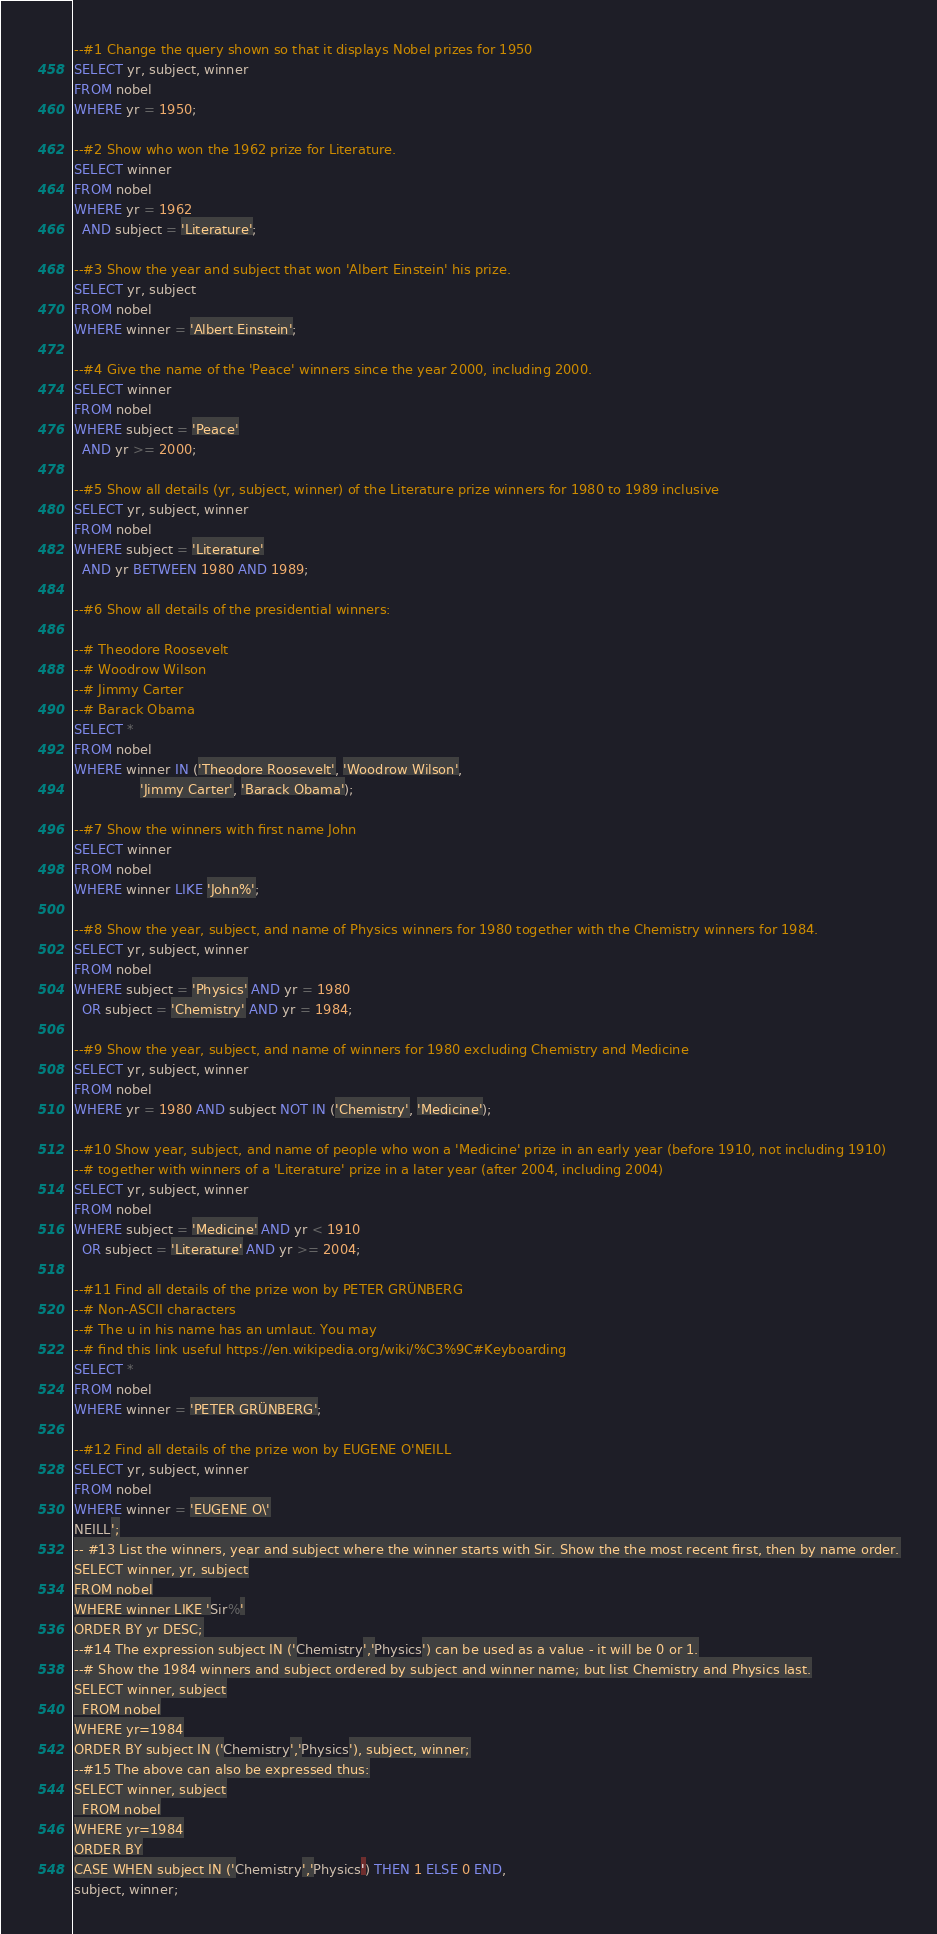Convert code to text. <code><loc_0><loc_0><loc_500><loc_500><_SQL_>--#1 Change the query shown so that it displays Nobel prizes for 1950
SELECT yr, subject, winner
FROM nobel
WHERE yr = 1950;

--#2 Show who won the 1962 prize for Literature.
SELECT winner
FROM nobel
WHERE yr = 1962
  AND subject = 'Literature';

--#3 Show the year and subject that won 'Albert Einstein' his prize.
SELECT yr, subject
FROM nobel
WHERE winner = 'Albert Einstein';

--#4 Give the name of the 'Peace' winners since the year 2000, including 2000.
SELECT winner
FROM nobel
WHERE subject = 'Peace'
  AND yr >= 2000;

--#5 Show all details (yr, subject, winner) of the Literature prize winners for 1980 to 1989 inclusive
SELECT yr, subject, winner
FROM nobel
WHERE subject = 'Literature'
  AND yr BETWEEN 1980 AND 1989;

--#6 Show all details of the presidential winners:

--# Theodore Roosevelt
--# Woodrow Wilson
--# Jimmy Carter
--# Barack Obama
SELECT *
FROM nobel
WHERE winner IN ('Theodore Roosevelt', 'Woodrow Wilson',
                'Jimmy Carter', 'Barack Obama');

--#7 Show the winners with first name John
SELECT winner
FROM nobel
WHERE winner LIKE 'John%';

--#8 Show the year, subject, and name of Physics winners for 1980 together with the Chemistry winners for 1984.
SELECT yr, subject, winner
FROM nobel
WHERE subject = 'Physics' AND yr = 1980
  OR subject = 'Chemistry' AND yr = 1984;

--#9 Show the year, subject, and name of winners for 1980 excluding Chemistry and Medicine
SELECT yr, subject, winner
FROM nobel
WHERE yr = 1980 AND subject NOT IN ('Chemistry', 'Medicine');

--#10 Show year, subject, and name of people who won a 'Medicine' prize in an early year (before 1910, not including 1910)
--# together with winners of a 'Literature' prize in a later year (after 2004, including 2004)
SELECT yr, subject, winner
FROM nobel
WHERE subject = 'Medicine' AND yr < 1910
  OR subject = 'Literature' AND yr >= 2004;

--#11 Find all details of the prize won by PETER GRÜNBERG
--# Non-ASCII characters
--# The u in his name has an umlaut. You may
--# find this link useful https://en.wikipedia.org/wiki/%C3%9C#Keyboarding
SELECT *
FROM nobel
WHERE winner = 'PETER GRÜNBERG';

--#12 Find all details of the prize won by EUGENE O'NEILL
SELECT yr, subject, winner
FROM nobel
WHERE winner = 'EUGENE O\'
NEILL';
-- #13 List the winners, year and subject where the winner starts with Sir. Show the the most recent first, then by name order.
SELECT winner, yr, subject
FROM nobel
WHERE winner LIKE 'Sir%'
ORDER BY yr DESC;
--#14 The expression subject IN ('Chemistry','Physics') can be used as a value - it will be 0 or 1.
--# Show the 1984 winners and subject ordered by subject and winner name; but list Chemistry and Physics last.
SELECT winner, subject
  FROM nobel
WHERE yr=1984
ORDER BY subject IN ('Chemistry','Physics'), subject, winner;
--#15 The above can also be expressed thus:
SELECT winner, subject
  FROM nobel
WHERE yr=1984
ORDER BY
CASE WHEN subject IN ('Chemistry','Physics') THEN 1 ELSE 0 END,
subject, winner;</code> 